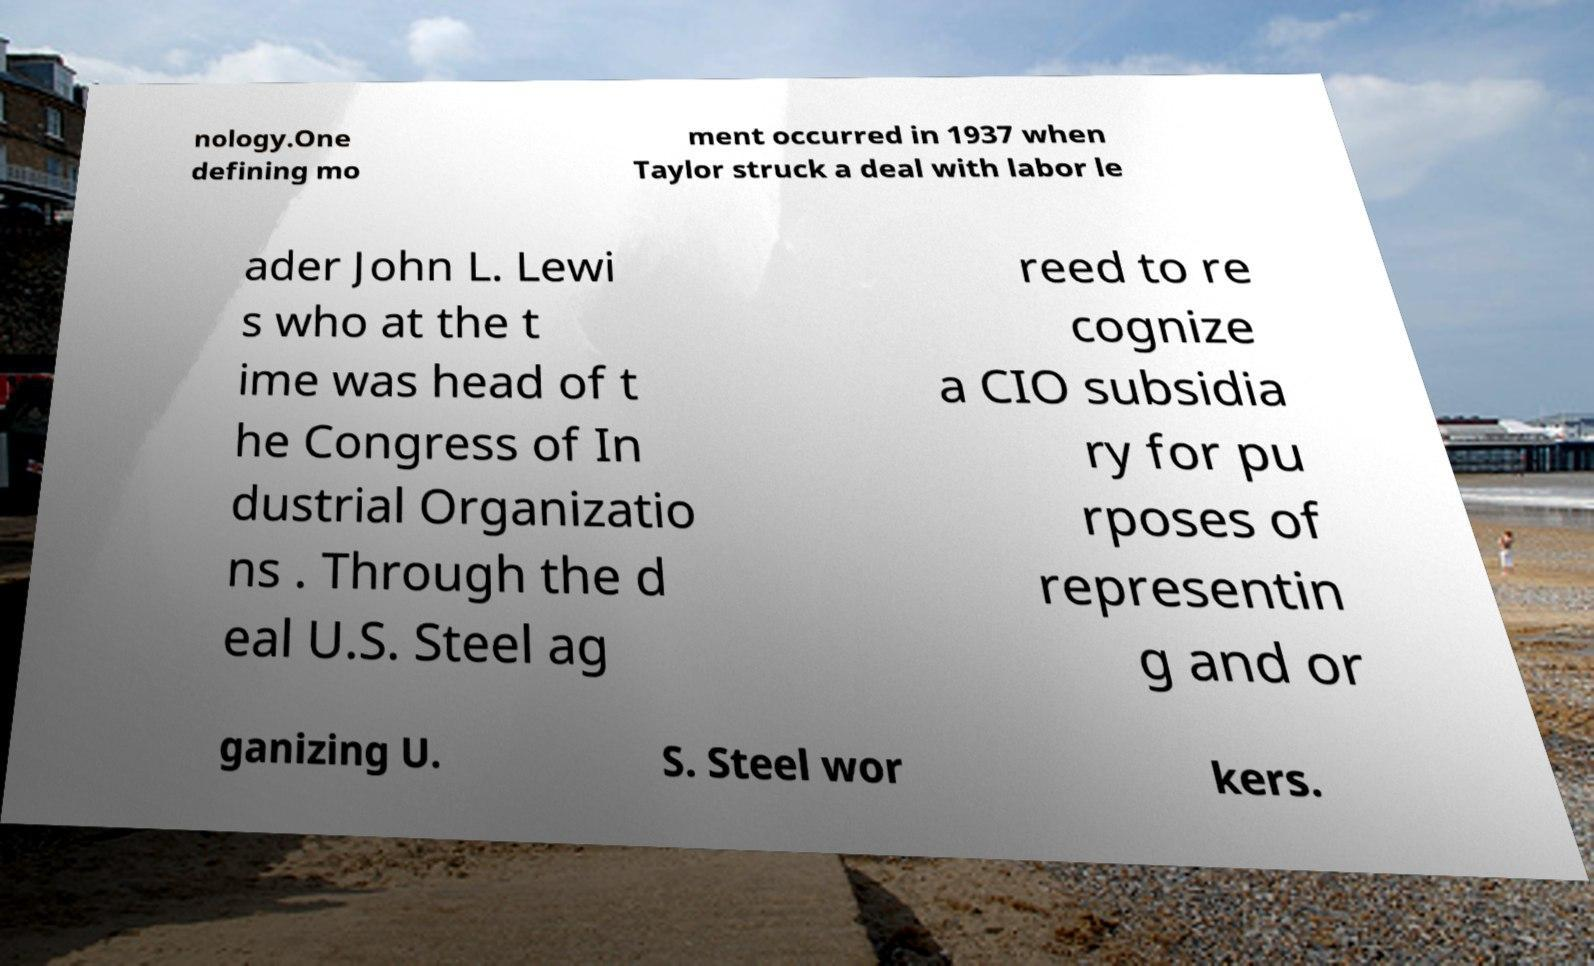Could you extract and type out the text from this image? nology.One defining mo ment occurred in 1937 when Taylor struck a deal with labor le ader John L. Lewi s who at the t ime was head of t he Congress of In dustrial Organizatio ns . Through the d eal U.S. Steel ag reed to re cognize a CIO subsidia ry for pu rposes of representin g and or ganizing U. S. Steel wor kers. 